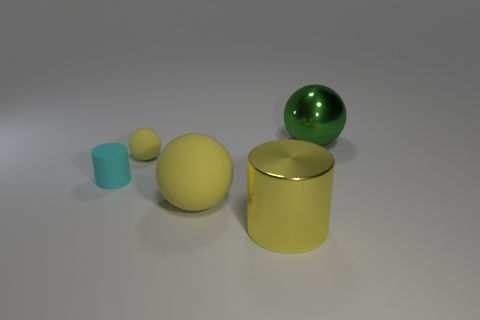How would you categorize the objects in the image by their shape? The objects can be categorized by their geometric shapes. There's the cylindrical shapes which are the cyan and the large yellow cylinder. Then there are spheres which include the green sphere and the large yellow ball. The categorization by shape highlights their geometric nature and simplicity of form. 